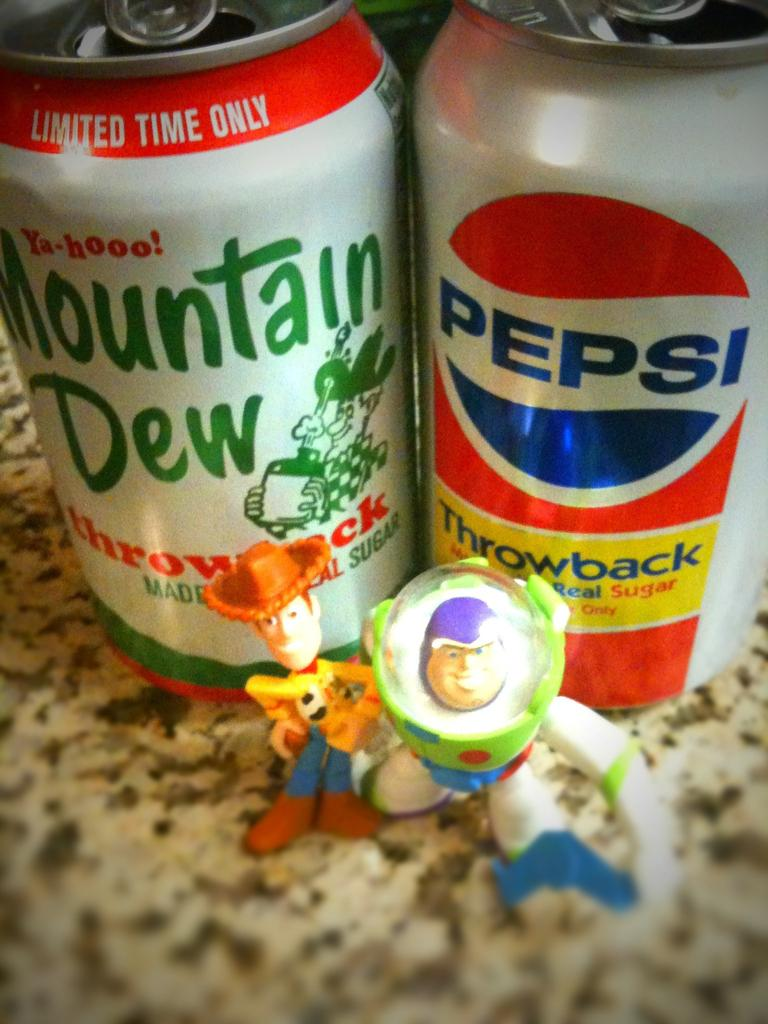What type of beverage containers are in the image? There are two soft drink tins in the image. What other items can be seen in the image besides the soft drink tins? There are two toys visible in the image. Where are the soft drink tins and toys located in the image? The soft drink tins and toys are on the floor in the image. What type of grain can be seen growing in the image? There is no grain present in the image. How many bananas are visible in the image? There are no bananas present in the image. 